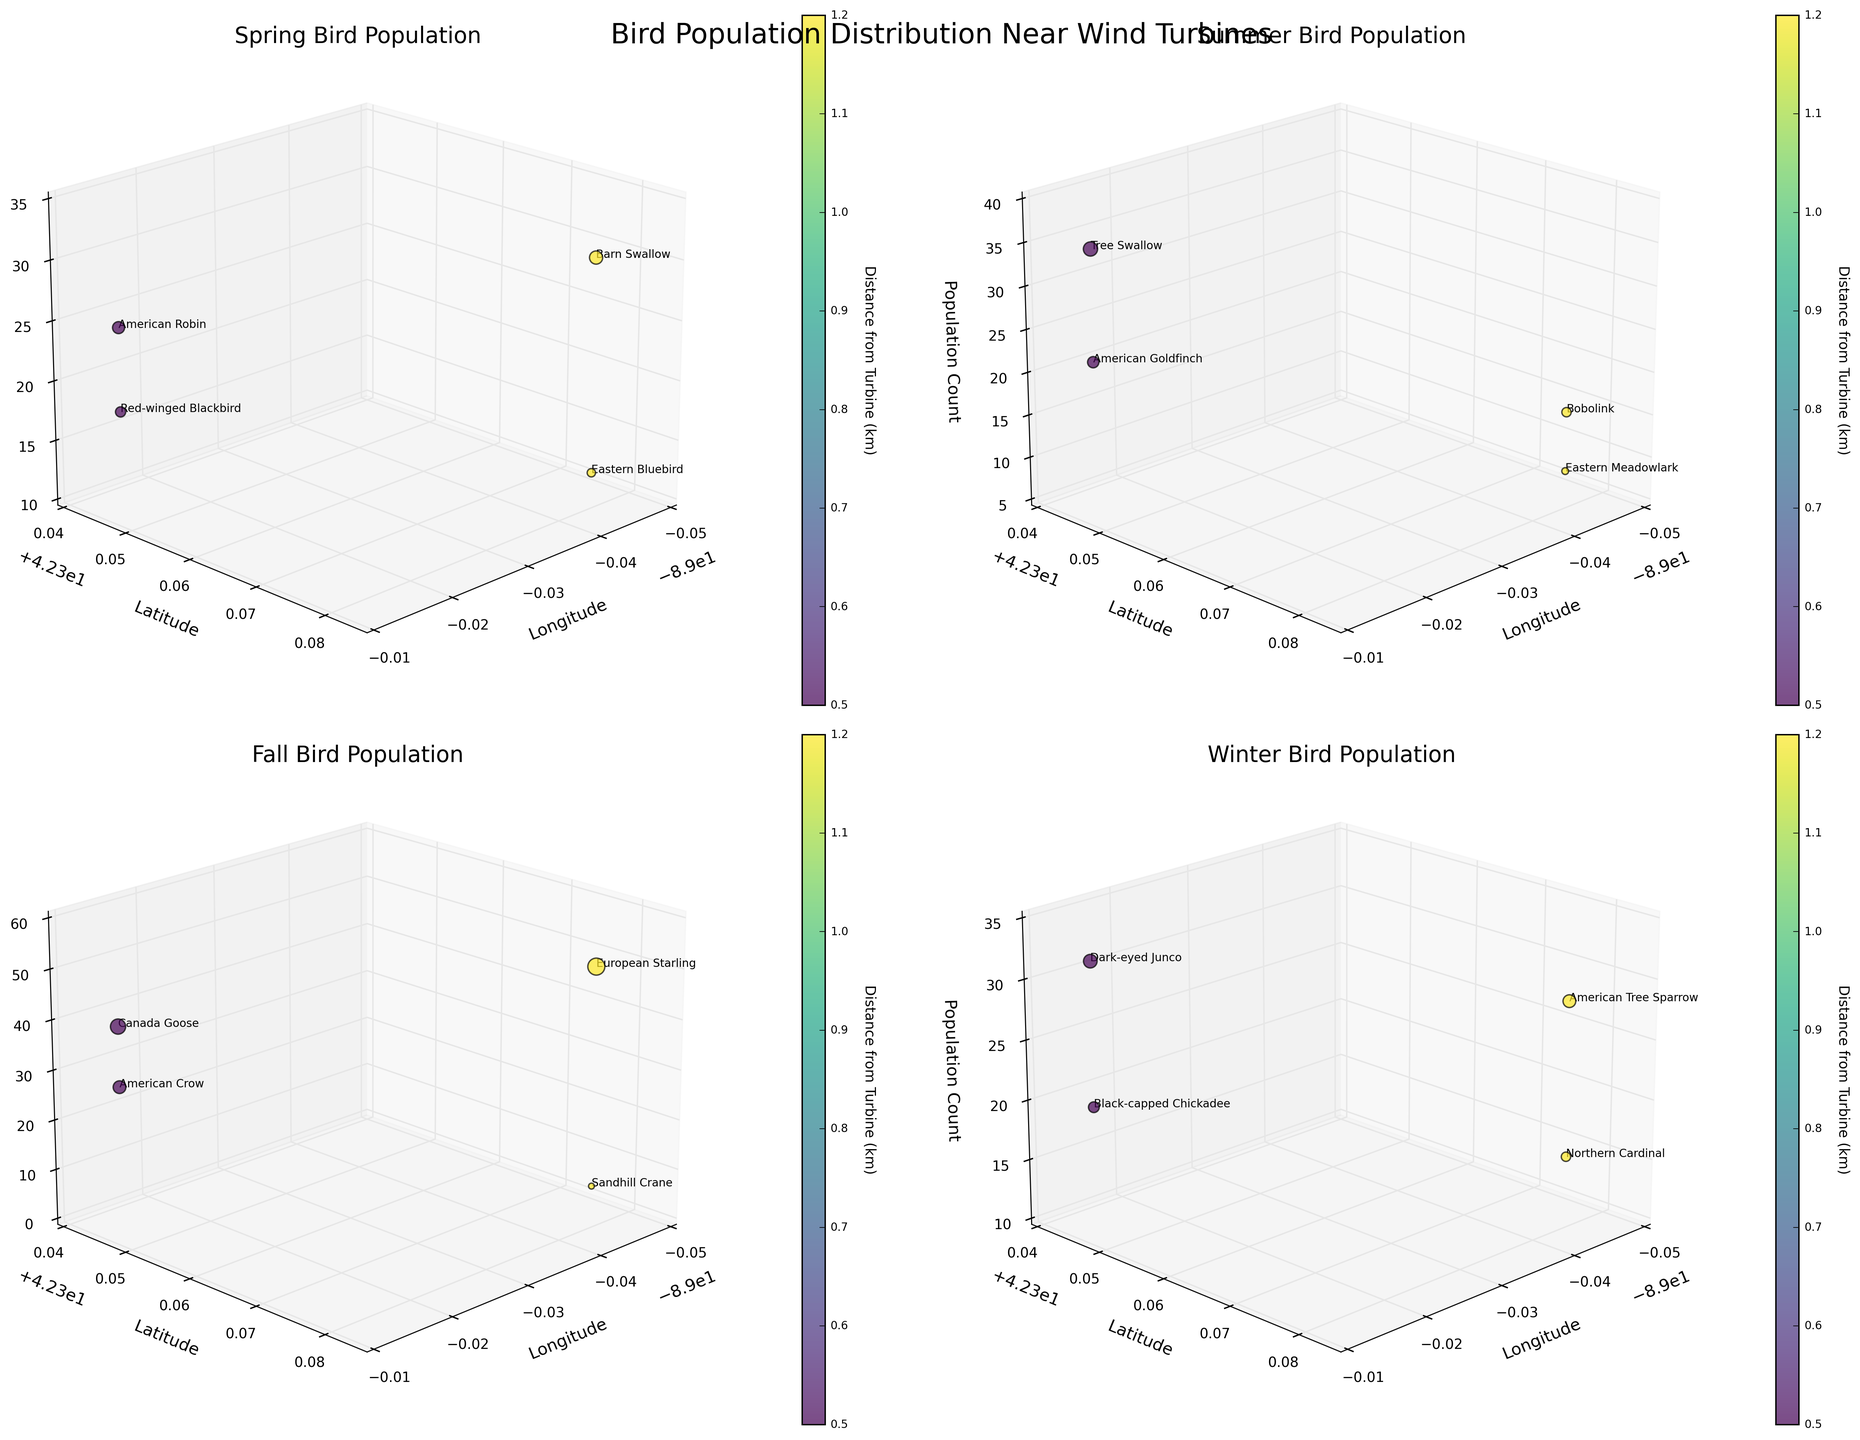What season displays the highest bird population around Wind Turbine 001? To answer this, we need to look at the 3D plots for each season and identify the season with the highest bird population around the coordinates of Wind Turbine 001. Spring has American Robin (25) and Red-winged Blackbird (18), Summer has American Goldfinch (22) and Tree Swallow (35), Fall has Canada Goose (40) and American Crow (28), and Winter has Dark-eyed Junco (32) and Black-capped Chickadee (20). Adding these up, Fall has the highest total population.
Answer: Fall Which turbine has the highest bird population in Summer? In the Summer subplot, we should compare the bird population sizes around both Wind Turbine 001 and WT002. WT001 has American Goldfinch (22) and Tree Swallow (35), while WT002 has Eastern Meadowlark (8) and Bobolink (15). Summing these, WT001 has a combined population of 57, while WT002 has 23.
Answer: WT001 During which season is the population count near WT002 closest to 50? Comparing the population counts for WT002 for each season: Spring (12+30=42), Summer (8+15=23), Fall (6+50=56), Winter (15+28=43). The Fall season's 56 is closest to 50.
Answer: Fall What color represents the smallest distance from a wind turbine? The color scheme used in the figure is a gradient, where darker shades (typically used for low values in viridis colormap) represent smaller distances. The green closest to dark represents the smallest distance.
Answer: Dark green Does any bird species text label appear more than once across seasons? By reviewing the text labels in each subplot, we observe that no bird species repeats across different seasons. Each species appears only once.
Answer: No Which species is found at the furthest distance from a turbine in Spring? In the Spring subplot, WT002 has Eastern Bluebird (12) and Barn Swallow (30) at 1.2 km. At WT001, American Robin (25) and Red-winged Blackbird (18) are at 0.5 km. Thus, Eastern Bluebird and Barn Swallow are at the furthest distance.
Answer: Eastern Bluebird and Barn Swallow Which season shows the highest variety of bird species? To find this, count the number of unique bird species per season in each subplot. Spring has 4 species, Summer has 4, Fall has 4, and Winter has 4. Every season displays the same variety.
Answer: All seasons What is the trend of bird population distribution in relation to turbine distance? Observing the plots, it's seen that populations are generally denser closer to the turbines (lower distances) and more dispersed (sparser) at longer distances.
Answer: Denser closer Which bird species has the highest recorded population in the entire data set? By inspecting each subplot, we find that European Starling (50) in Fall has the highest population count among all species across the seasons.
Answer: European Starling Is there any season where the bird populations around both turbines are nearly equal? Compute total populations around WT001 and WT002 for each season. Spring (43 vs. 42), Summer (57 vs. 23), Fall (68 vs. 56), Winter (52 vs. 43). Only in Spring, the populations are nearly equal with a small difference.
Answer: Spring 